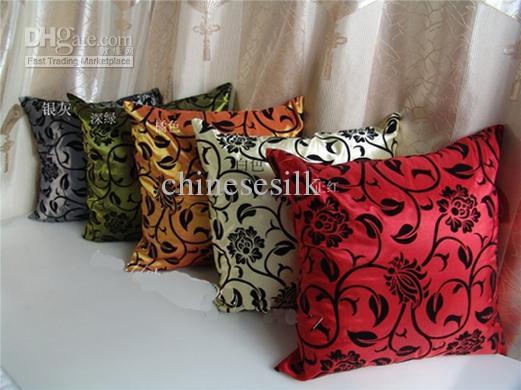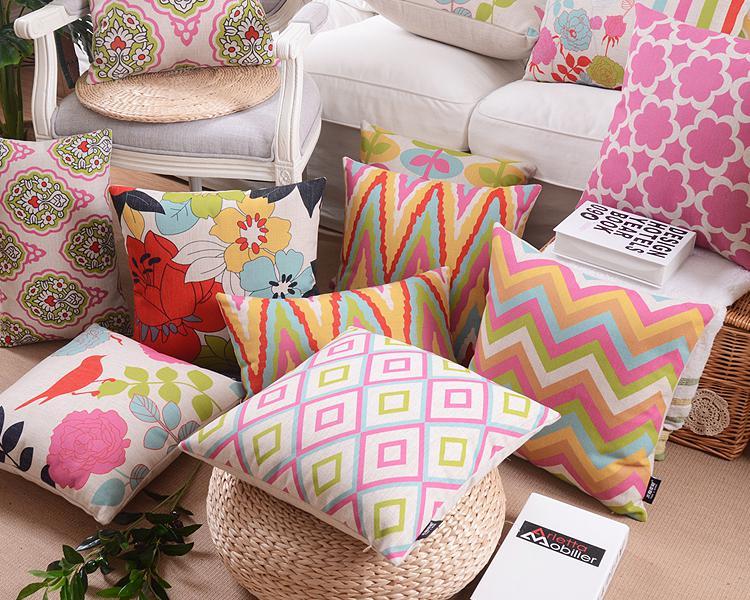The first image is the image on the left, the second image is the image on the right. Evaluate the accuracy of this statement regarding the images: "The left image has exactly five pillows.". Is it true? Answer yes or no. Yes. The first image is the image on the left, the second image is the image on the right. Examine the images to the left and right. Is the description "All of the pillows in one image feature multicolored birds on branches and have a pale neutral background color." accurate? Answer yes or no. No. 